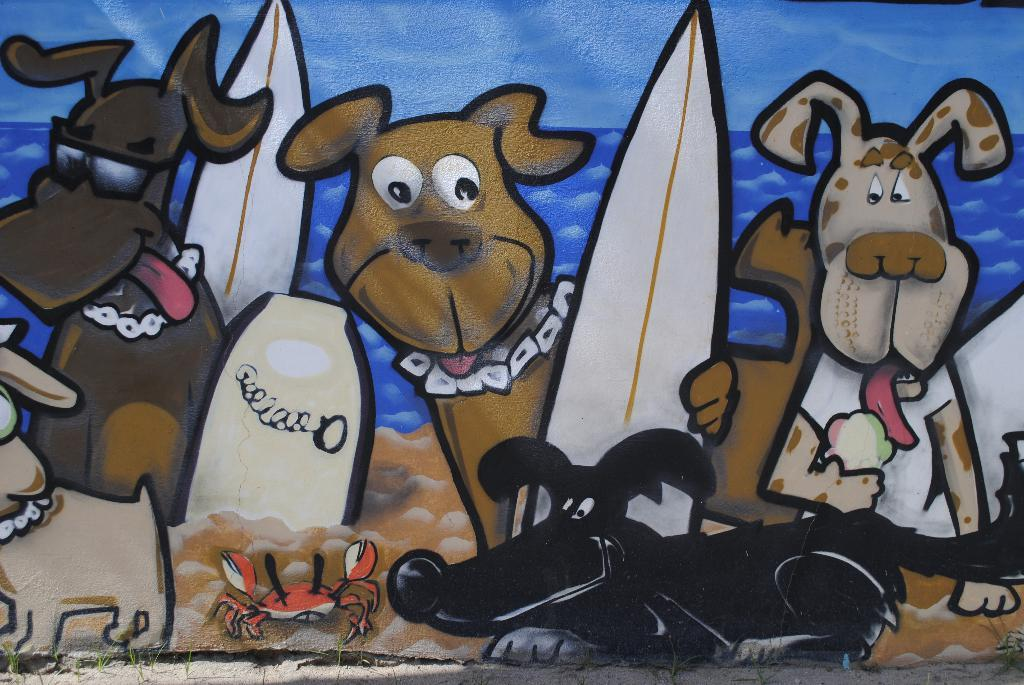What is on the wall in the image? There is a painting on the wall in the image. Where is the toy throne located in the image? There is no toy throne present in the image; it only features a painting on the wall. 